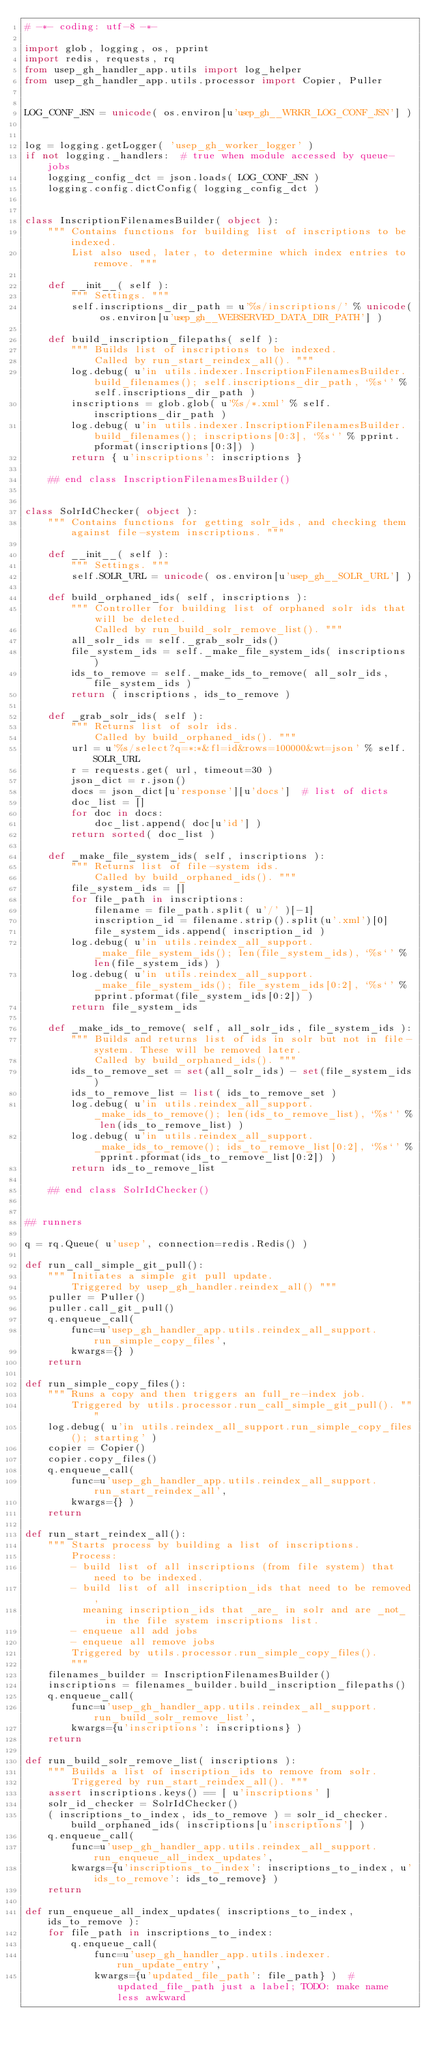Convert code to text. <code><loc_0><loc_0><loc_500><loc_500><_Python_># -*- coding: utf-8 -*-

import glob, logging, os, pprint
import redis, requests, rq
from usep_gh_handler_app.utils import log_helper
from usep_gh_handler_app.utils.processor import Copier, Puller


LOG_CONF_JSN = unicode( os.environ[u'usep_gh__WRKR_LOG_CONF_JSN'] )


log = logging.getLogger( 'usep_gh_worker_logger' )
if not logging._handlers:  # true when module accessed by queue-jobs
    logging_config_dct = json.loads( LOG_CONF_JSN )
    logging.config.dictConfig( logging_config_dct )


class InscriptionFilenamesBuilder( object ):
    """ Contains functions for building list of inscriptions to be indexed.
        List also used, later, to determine which index entries to remove. """

    def __init__( self ):
        """ Settings. """
        self.inscriptions_dir_path = u'%s/inscriptions/' % unicode( os.environ[u'usep_gh__WEBSERVED_DATA_DIR_PATH'] )

    def build_inscription_filepaths( self ):
        """ Builds list of inscriptions to be indexed.
            Called by run_start_reindex_all(). """
        log.debug( u'in utils.indexer.InscriptionFilenamesBuilder.build_filenames(); self.inscriptions_dir_path, `%s`' % self.inscriptions_dir_path )
        inscriptions = glob.glob( u'%s/*.xml' % self.inscriptions_dir_path )
        log.debug( u'in utils.indexer.InscriptionFilenamesBuilder.build_filenames(); inscriptions[0:3], `%s`' % pprint.pformat(inscriptions[0:3]) )
        return { u'inscriptions': inscriptions }

    ## end class InscriptionFilenamesBuilder()


class SolrIdChecker( object ):
    """ Contains functions for getting solr_ids, and checking them against file-system inscriptions. """

    def __init__( self ):
        """ Settings. """
        self.SOLR_URL = unicode( os.environ[u'usep_gh__SOLR_URL'] )

    def build_orphaned_ids( self, inscriptions ):
        """ Controller for building list of orphaned solr ids that will be deleted.
            Called by run_build_solr_remove_list(). """
        all_solr_ids = self._grab_solr_ids()
        file_system_ids = self._make_file_system_ids( inscriptions )
        ids_to_remove = self._make_ids_to_remove( all_solr_ids, file_system_ids )
        return ( inscriptions, ids_to_remove )

    def _grab_solr_ids( self ):
        """ Returns list of solr ids.
            Called by build_orphaned_ids(). """
        url = u'%s/select?q=*:*&fl=id&rows=100000&wt=json' % self.SOLR_URL
        r = requests.get( url, timeout=30 )
        json_dict = r.json()
        docs = json_dict[u'response'][u'docs']  # list of dicts
        doc_list = []
        for doc in docs:
            doc_list.append( doc[u'id'] )
        return sorted( doc_list )

    def _make_file_system_ids( self, inscriptions ):
        """ Returns list of file-system ids.
            Called by build_orphaned_ids(). """
        file_system_ids = []
        for file_path in inscriptions:
            filename = file_path.split( u'/' )[-1]
            inscription_id = filename.strip().split(u'.xml')[0]
            file_system_ids.append( inscription_id )
        log.debug( u'in utils.reindex_all_support._make_file_system_ids(); len(file_system_ids), `%s`' % len(file_system_ids) )
        log.debug( u'in utils.reindex_all_support._make_file_system_ids(); file_system_ids[0:2], `%s`' % pprint.pformat(file_system_ids[0:2]) )
        return file_system_ids

    def _make_ids_to_remove( self, all_solr_ids, file_system_ids ):
        """ Builds and returns list of ids in solr but not in file-system. These will be removed later.
            Called by build_orphaned_ids(). """
        ids_to_remove_set = set(all_solr_ids) - set(file_system_ids)
        ids_to_remove_list = list( ids_to_remove_set )
        log.debug( u'in utils.reindex_all_support._make_ids_to_remove(); len(ids_to_remove_list), `%s`' % len(ids_to_remove_list) )
        log.debug( u'in utils.reindex_all_support._make_ids_to_remove(); ids_to_remove_list[0:2], `%s`' % pprint.pformat(ids_to_remove_list[0:2]) )
        return ids_to_remove_list

    ## end class SolrIdChecker()


## runners

q = rq.Queue( u'usep', connection=redis.Redis() )

def run_call_simple_git_pull():
    """ Initiates a simple git pull update.
        Triggered by usep_gh_handler.reindex_all() """
    puller = Puller()
    puller.call_git_pull()
    q.enqueue_call(
        func=u'usep_gh_handler_app.utils.reindex_all_support.run_simple_copy_files',
        kwargs={} )
    return

def run_simple_copy_files():
    """ Runs a copy and then triggers an full_re-index job.
        Triggered by utils.processor.run_call_simple_git_pull(). """
    log.debug( u'in utils.reindex_all_support.run_simple_copy_files(); starting' )
    copier = Copier()
    copier.copy_files()
    q.enqueue_call(
        func=u'usep_gh_handler_app.utils.reindex_all_support.run_start_reindex_all',
        kwargs={} )
    return

def run_start_reindex_all():
    """ Starts process by building a list of inscriptions.
        Process:
        - build list of all inscriptions (from file system) that need to be indexed.
        - build list of all inscription_ids that need to be removed,
          meaning inscription_ids that _are_ in solr and are _not_ in the file system inscriptions list.
        - enqueue all add jobs
        - enqueue all remove jobs
        Triggered by utils.processor.run_simple_copy_files().
        """
    filenames_builder = InscriptionFilenamesBuilder()
    inscriptions = filenames_builder.build_inscription_filepaths()
    q.enqueue_call(
        func=u'usep_gh_handler_app.utils.reindex_all_support.run_build_solr_remove_list',
        kwargs={u'inscriptions': inscriptions} )
    return

def run_build_solr_remove_list( inscriptions ):
    """ Builds a list of inscription_ids to remove from solr.
        Triggered by run_start_reindex_all(). """
    assert inscriptions.keys() == [ u'inscriptions' ]
    solr_id_checker = SolrIdChecker()
    ( inscriptions_to_index, ids_to_remove ) = solr_id_checker.build_orphaned_ids( inscriptions[u'inscriptions'] )
    q.enqueue_call(
        func=u'usep_gh_handler_app.utils.reindex_all_support.run_enqueue_all_index_updates',
        kwargs={u'inscriptions_to_index': inscriptions_to_index, u'ids_to_remove': ids_to_remove} )
    return

def run_enqueue_all_index_updates( inscriptions_to_index, ids_to_remove ):
    for file_path in inscriptions_to_index:
        q.enqueue_call(
            func=u'usep_gh_handler_app.utils.indexer.run_update_entry',
            kwargs={u'updated_file_path': file_path} )  # updated_file_path just a label; TODO: make name less awkward</code> 